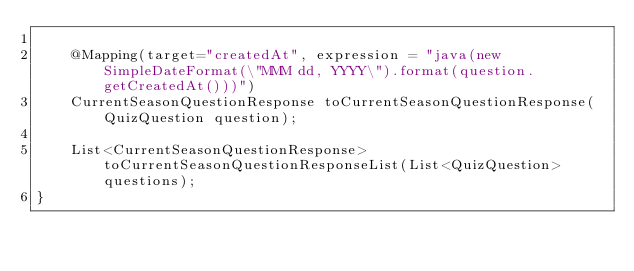<code> <loc_0><loc_0><loc_500><loc_500><_Java_>
    @Mapping(target="createdAt", expression = "java(new SimpleDateFormat(\"MMM dd, YYYY\").format(question.getCreatedAt()))")
    CurrentSeasonQuestionResponse toCurrentSeasonQuestionResponse(QuizQuestion question);

    List<CurrentSeasonQuestionResponse> toCurrentSeasonQuestionResponseList(List<QuizQuestion> questions);
}
</code> 